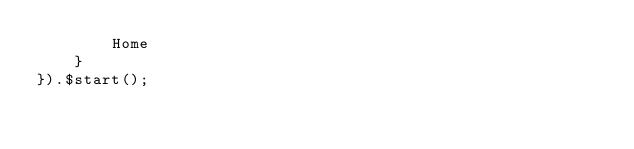<code> <loc_0><loc_0><loc_500><loc_500><_TypeScript_>        Home
    }
}).$start();
</code> 